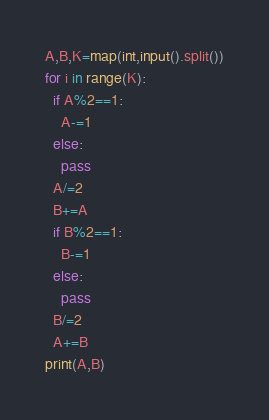Convert code to text. <code><loc_0><loc_0><loc_500><loc_500><_Python_>A,B,K=map(int,input().split())
for i in range(K):
  if A%2==1:
    A-=1
  else:
    pass
  A/=2
  B+=A
  if B%2==1:
    B-=1
  else:
    pass
  B/=2
  A+=B
print(A,B)  </code> 